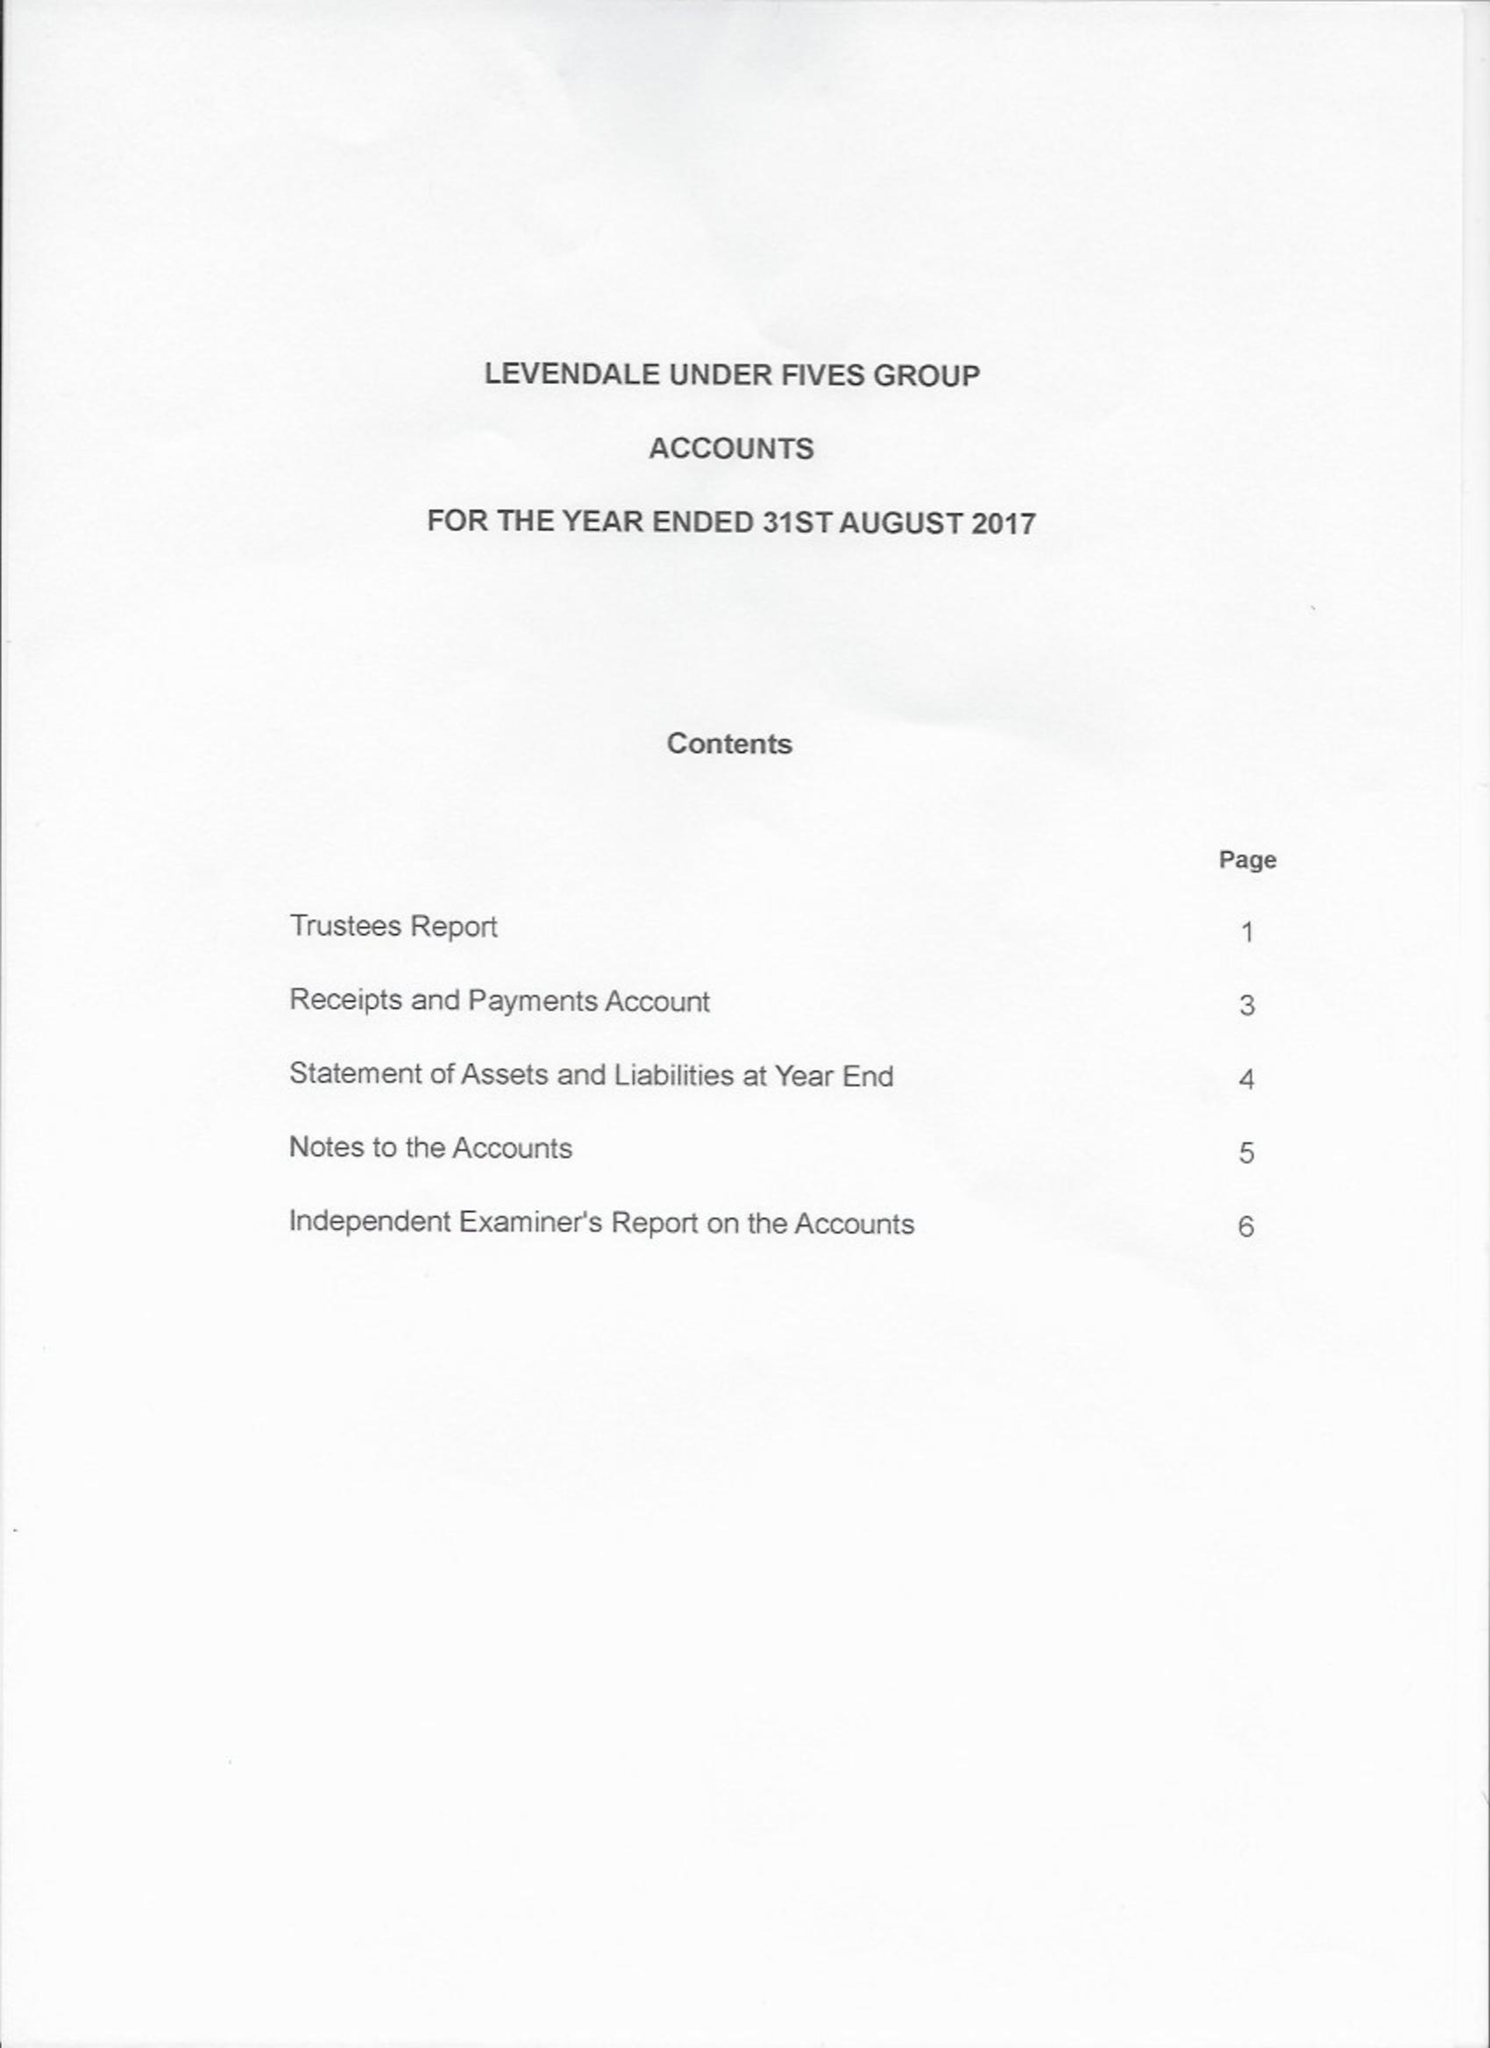What is the value for the report_date?
Answer the question using a single word or phrase. 2017-08-31 